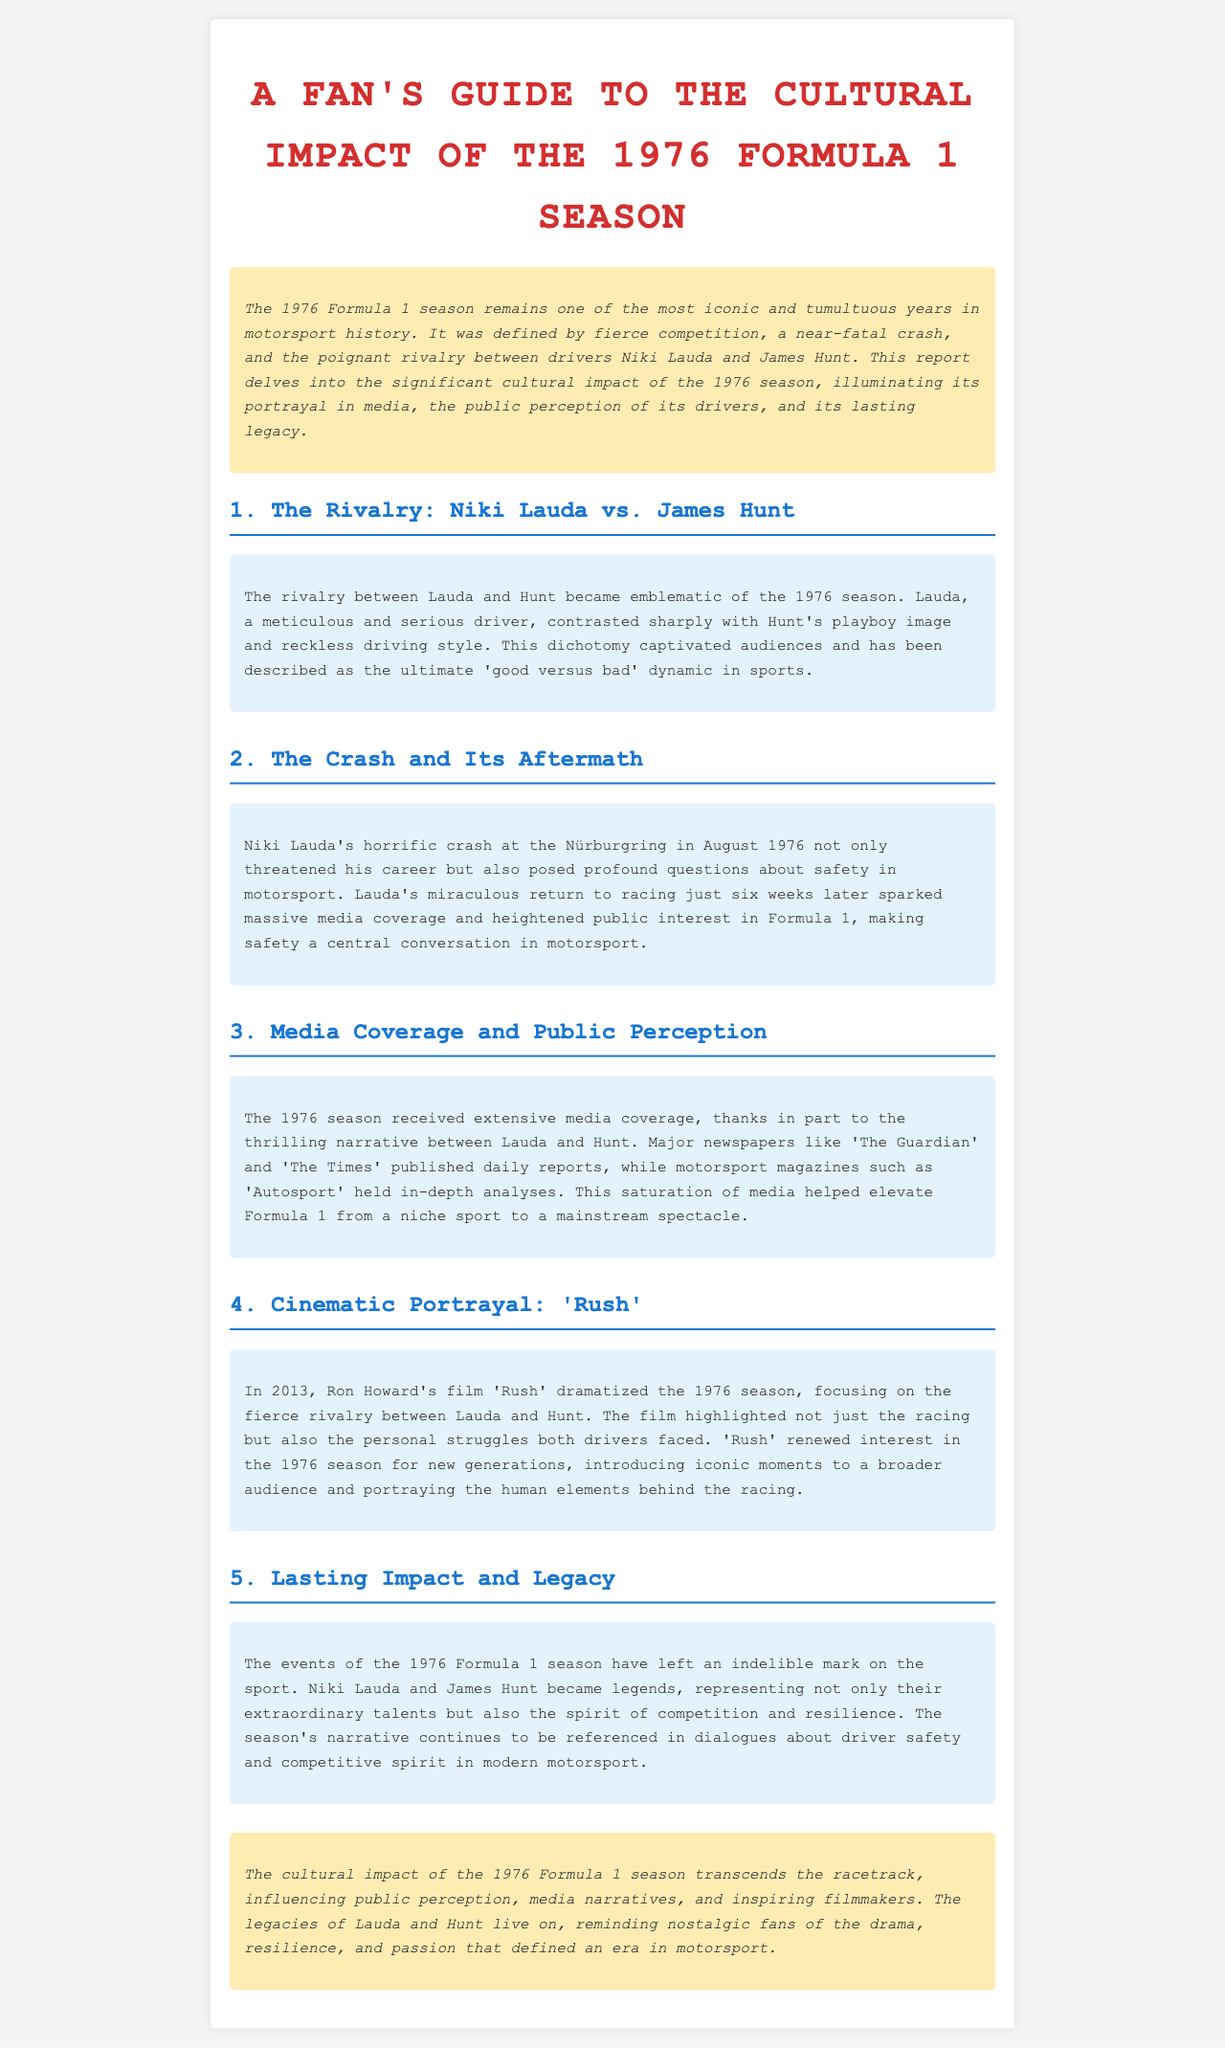What was the primary rivalry in the 1976 Formula 1 season? The document highlights the rivalry between Niki Lauda and James Hunt as the primary focus of the 1976 season.
Answer: Niki Lauda and James Hunt What significant event occurred at the Nürburgring in 1976? The document notes that Niki Lauda had a horrific crash at the Nürburgring, marking a key moment in the season.
Answer: A horrific crash What film dramatized the 1976 Formula 1 season? The document states that Ron Howard's film 'Rush' dramatized the 1976 season, focusing on Lauda and Hunt's rivalry.
Answer: Rush How did Lauda's crash affect media coverage? The document mentions that Lauda's return to racing sparked massive media coverage and heightened public interest in Formula 1.
Answer: Sparked massive media coverage What year did the events of the 1976 Formula 1 season leave a lasting impact? The report indicates the 1976 season still references in dialogues about driver safety and competition today.
Answer: 1976 What contrasting images were portrayed by Lauda and Hunt? The document describes Lauda as a meticulous and serious driver, which contrasted sharply with Hunt's playboy image.
Answer: Meticulous and serious vs. playboy image How did the 1976 season contribute to the public perception of Formula 1? The extensive media coverage helped elevate Formula 1 from a niche sport to a mainstream spectacle.
Answer: Mainstream spectacle 